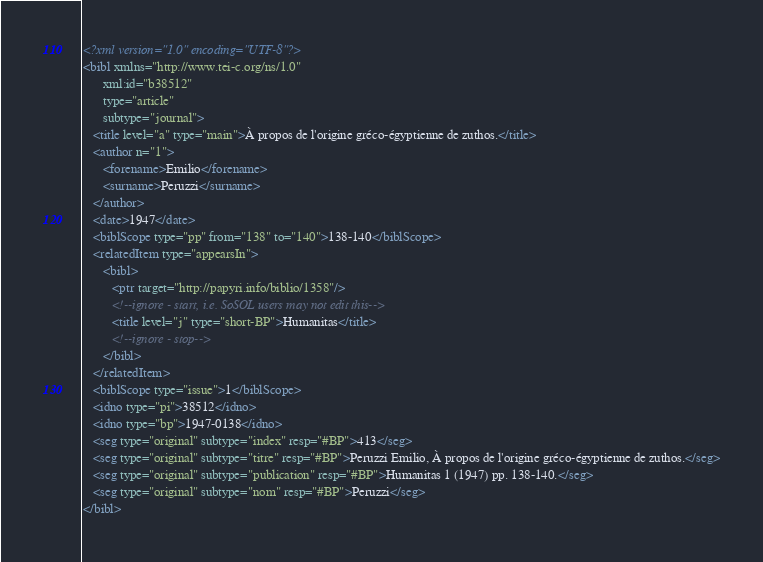<code> <loc_0><loc_0><loc_500><loc_500><_XML_><?xml version="1.0" encoding="UTF-8"?>
<bibl xmlns="http://www.tei-c.org/ns/1.0"
      xml:id="b38512"
      type="article"
      subtype="journal">
   <title level="a" type="main">À propos de l'origine gréco-égyptienne de zuthos.</title>
   <author n="1">
      <forename>Emilio</forename>
      <surname>Peruzzi</surname>
   </author>
   <date>1947</date>
   <biblScope type="pp" from="138" to="140">138-140</biblScope>
   <relatedItem type="appearsIn">
      <bibl>
         <ptr target="http://papyri.info/biblio/1358"/>
         <!--ignore - start, i.e. SoSOL users may not edit this-->
         <title level="j" type="short-BP">Humanitas</title>
         <!--ignore - stop-->
      </bibl>
   </relatedItem>
   <biblScope type="issue">1</biblScope>
   <idno type="pi">38512</idno>
   <idno type="bp">1947-0138</idno>
   <seg type="original" subtype="index" resp="#BP">413</seg>
   <seg type="original" subtype="titre" resp="#BP">Peruzzi Emilio, À propos de l'origine gréco-égyptienne de zuthos.</seg>
   <seg type="original" subtype="publication" resp="#BP">Humanitas 1 (1947) pp. 138-140.</seg>
   <seg type="original" subtype="nom" resp="#BP">Peruzzi</seg>
</bibl>
</code> 